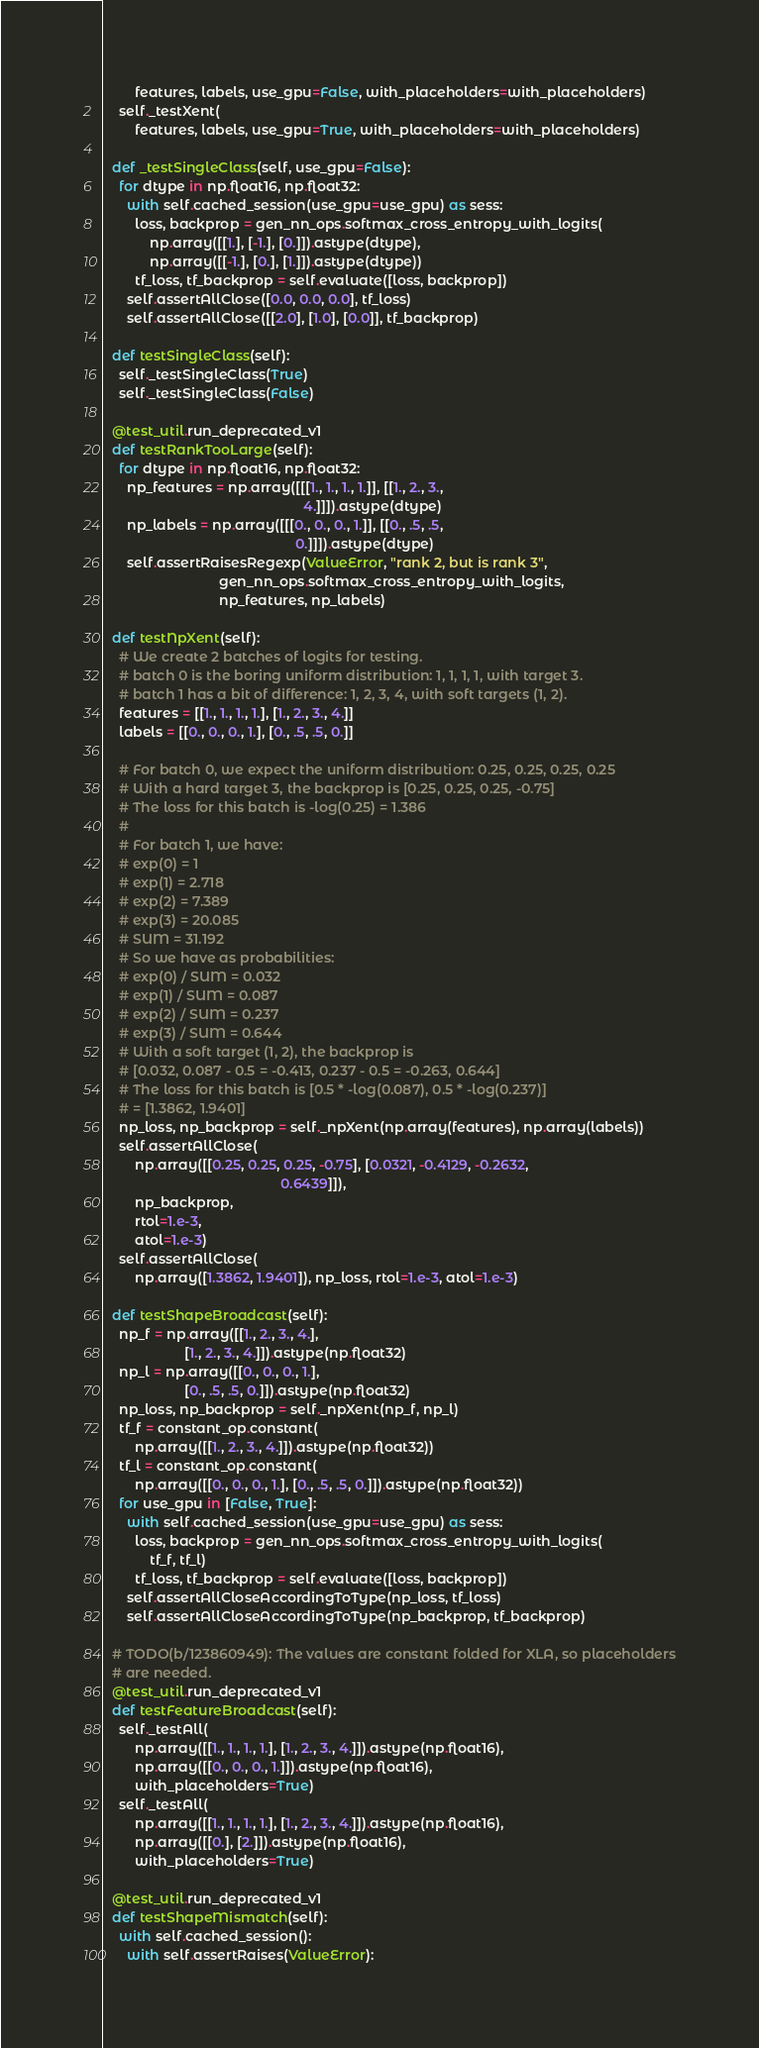Convert code to text. <code><loc_0><loc_0><loc_500><loc_500><_Python_>        features, labels, use_gpu=False, with_placeholders=with_placeholders)
    self._testXent(
        features, labels, use_gpu=True, with_placeholders=with_placeholders)

  def _testSingleClass(self, use_gpu=False):
    for dtype in np.float16, np.float32:
      with self.cached_session(use_gpu=use_gpu) as sess:
        loss, backprop = gen_nn_ops.softmax_cross_entropy_with_logits(
            np.array([[1.], [-1.], [0.]]).astype(dtype),
            np.array([[-1.], [0.], [1.]]).astype(dtype))
        tf_loss, tf_backprop = self.evaluate([loss, backprop])
      self.assertAllClose([0.0, 0.0, 0.0], tf_loss)
      self.assertAllClose([[2.0], [1.0], [0.0]], tf_backprop)

  def testSingleClass(self):
    self._testSingleClass(True)
    self._testSingleClass(False)

  @test_util.run_deprecated_v1
  def testRankTooLarge(self):
    for dtype in np.float16, np.float32:
      np_features = np.array([[[1., 1., 1., 1.]], [[1., 2., 3.,
                                                    4.]]]).astype(dtype)
      np_labels = np.array([[[0., 0., 0., 1.]], [[0., .5, .5,
                                                  0.]]]).astype(dtype)
      self.assertRaisesRegexp(ValueError, "rank 2, but is rank 3",
                              gen_nn_ops.softmax_cross_entropy_with_logits,
                              np_features, np_labels)

  def testNpXent(self):
    # We create 2 batches of logits for testing.
    # batch 0 is the boring uniform distribution: 1, 1, 1, 1, with target 3.
    # batch 1 has a bit of difference: 1, 2, 3, 4, with soft targets (1, 2).
    features = [[1., 1., 1., 1.], [1., 2., 3., 4.]]
    labels = [[0., 0., 0., 1.], [0., .5, .5, 0.]]

    # For batch 0, we expect the uniform distribution: 0.25, 0.25, 0.25, 0.25
    # With a hard target 3, the backprop is [0.25, 0.25, 0.25, -0.75]
    # The loss for this batch is -log(0.25) = 1.386
    #
    # For batch 1, we have:
    # exp(0) = 1
    # exp(1) = 2.718
    # exp(2) = 7.389
    # exp(3) = 20.085
    # SUM = 31.192
    # So we have as probabilities:
    # exp(0) / SUM = 0.032
    # exp(1) / SUM = 0.087
    # exp(2) / SUM = 0.237
    # exp(3) / SUM = 0.644
    # With a soft target (1, 2), the backprop is
    # [0.032, 0.087 - 0.5 = -0.413, 0.237 - 0.5 = -0.263, 0.644]
    # The loss for this batch is [0.5 * -log(0.087), 0.5 * -log(0.237)]
    # = [1.3862, 1.9401]
    np_loss, np_backprop = self._npXent(np.array(features), np.array(labels))
    self.assertAllClose(
        np.array([[0.25, 0.25, 0.25, -0.75], [0.0321, -0.4129, -0.2632,
                                              0.6439]]),
        np_backprop,
        rtol=1.e-3,
        atol=1.e-3)
    self.assertAllClose(
        np.array([1.3862, 1.9401]), np_loss, rtol=1.e-3, atol=1.e-3)

  def testShapeBroadcast(self):
    np_f = np.array([[1., 2., 3., 4.],
                     [1., 2., 3., 4.]]).astype(np.float32)
    np_l = np.array([[0., 0., 0., 1.],
                     [0., .5, .5, 0.]]).astype(np.float32)
    np_loss, np_backprop = self._npXent(np_f, np_l)
    tf_f = constant_op.constant(
        np.array([[1., 2., 3., 4.]]).astype(np.float32))
    tf_l = constant_op.constant(
        np.array([[0., 0., 0., 1.], [0., .5, .5, 0.]]).astype(np.float32))
    for use_gpu in [False, True]:
      with self.cached_session(use_gpu=use_gpu) as sess:
        loss, backprop = gen_nn_ops.softmax_cross_entropy_with_logits(
            tf_f, tf_l)
        tf_loss, tf_backprop = self.evaluate([loss, backprop])
      self.assertAllCloseAccordingToType(np_loss, tf_loss)
      self.assertAllCloseAccordingToType(np_backprop, tf_backprop)

  # TODO(b/123860949): The values are constant folded for XLA, so placeholders
  # are needed.
  @test_util.run_deprecated_v1
  def testFeatureBroadcast(self):
    self._testAll(
        np.array([[1., 1., 1., 1.], [1., 2., 3., 4.]]).astype(np.float16),
        np.array([[0., 0., 0., 1.]]).astype(np.float16),
        with_placeholders=True)
    self._testAll(
        np.array([[1., 1., 1., 1.], [1., 2., 3., 4.]]).astype(np.float16),
        np.array([[0.], [2.]]).astype(np.float16),
        with_placeholders=True)

  @test_util.run_deprecated_v1
  def testShapeMismatch(self):
    with self.cached_session():
      with self.assertRaises(ValueError):</code> 